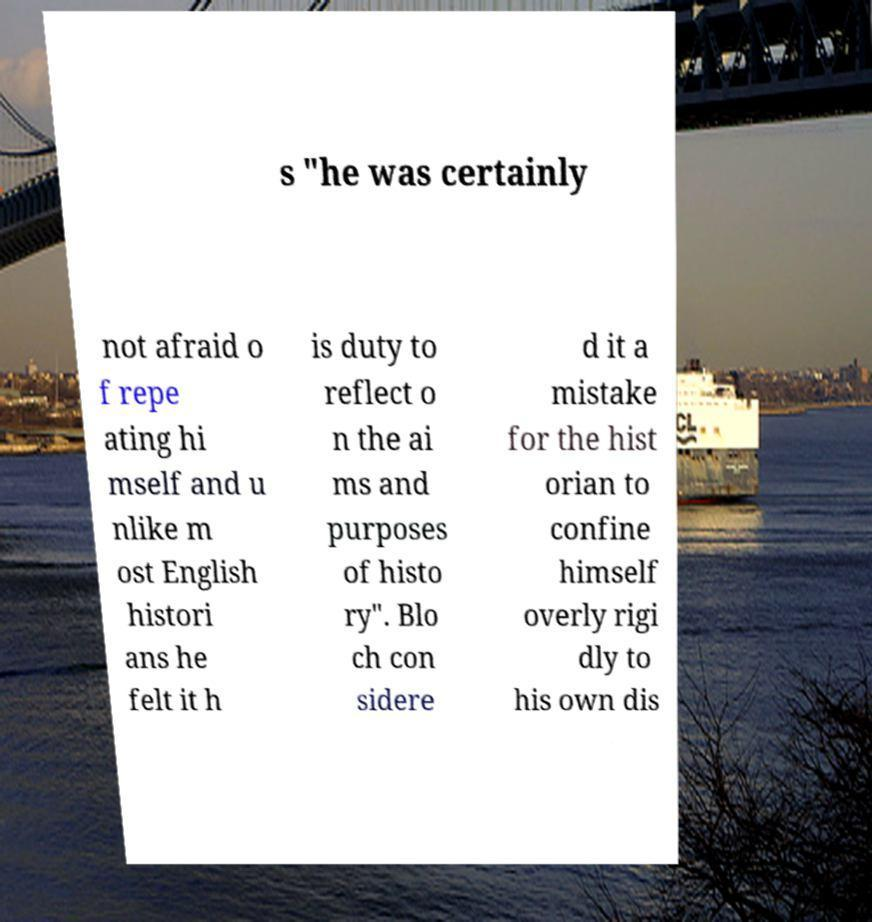Please read and relay the text visible in this image. What does it say? s "he was certainly not afraid o f repe ating hi mself and u nlike m ost English histori ans he felt it h is duty to reflect o n the ai ms and purposes of histo ry". Blo ch con sidere d it a mistake for the hist orian to confine himself overly rigi dly to his own dis 